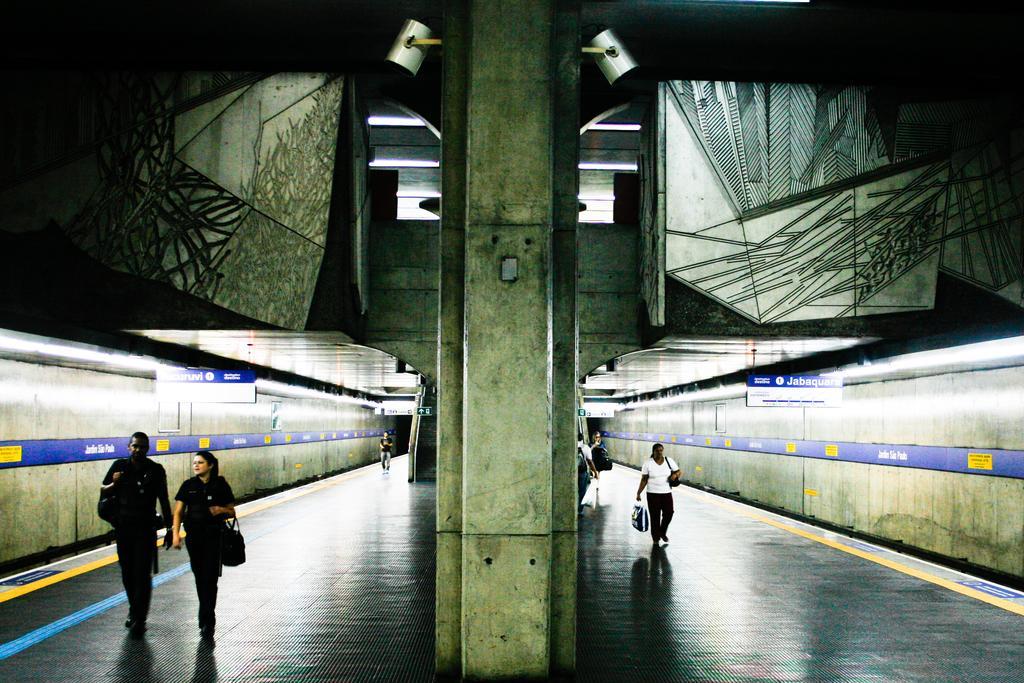Describe this image in one or two sentences. As we can see in the image there are few people here and there, wall and trains. 